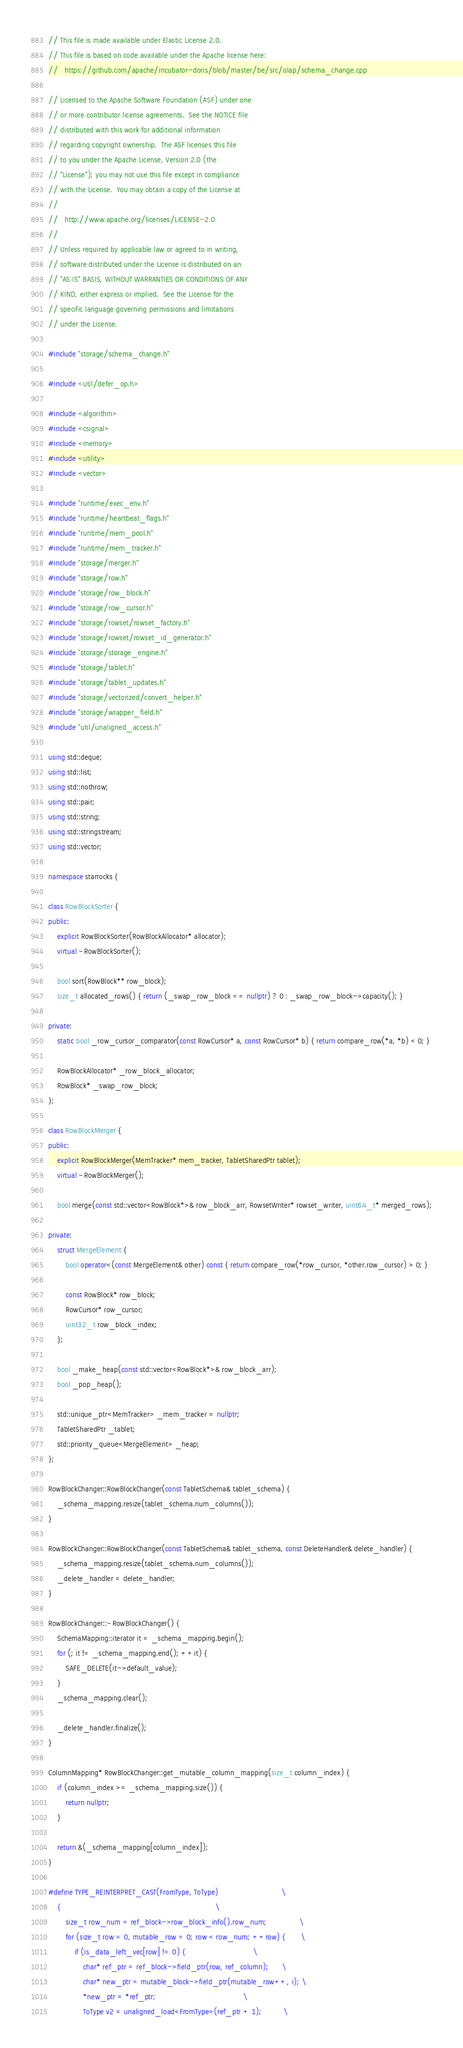Convert code to text. <code><loc_0><loc_0><loc_500><loc_500><_C++_>// This file is made available under Elastic License 2.0.
// This file is based on code available under the Apache license here:
//   https://github.com/apache/incubator-doris/blob/master/be/src/olap/schema_change.cpp

// Licensed to the Apache Software Foundation (ASF) under one
// or more contributor license agreements.  See the NOTICE file
// distributed with this work for additional information
// regarding copyright ownership.  The ASF licenses this file
// to you under the Apache License, Version 2.0 (the
// "License"); you may not use this file except in compliance
// with the License.  You may obtain a copy of the License at
//
//   http://www.apache.org/licenses/LICENSE-2.0
//
// Unless required by applicable law or agreed to in writing,
// software distributed under the License is distributed on an
// "AS IS" BASIS, WITHOUT WARRANTIES OR CONDITIONS OF ANY
// KIND, either express or implied.  See the License for the
// specific language governing permissions and limitations
// under the License.

#include "storage/schema_change.h"

#include <util/defer_op.h>

#include <algorithm>
#include <csignal>
#include <memory>
#include <utility>
#include <vector>

#include "runtime/exec_env.h"
#include "runtime/heartbeat_flags.h"
#include "runtime/mem_pool.h"
#include "runtime/mem_tracker.h"
#include "storage/merger.h"
#include "storage/row.h"
#include "storage/row_block.h"
#include "storage/row_cursor.h"
#include "storage/rowset/rowset_factory.h"
#include "storage/rowset/rowset_id_generator.h"
#include "storage/storage_engine.h"
#include "storage/tablet.h"
#include "storage/tablet_updates.h"
#include "storage/vectorized/convert_helper.h"
#include "storage/wrapper_field.h"
#include "util/unaligned_access.h"

using std::deque;
using std::list;
using std::nothrow;
using std::pair;
using std::string;
using std::stringstream;
using std::vector;

namespace starrocks {

class RowBlockSorter {
public:
    explicit RowBlockSorter(RowBlockAllocator* allocator);
    virtual ~RowBlockSorter();

    bool sort(RowBlock** row_block);
    size_t allocated_rows() { return (_swap_row_block == nullptr) ? 0 : _swap_row_block->capacity(); }

private:
    static bool _row_cursor_comparator(const RowCursor* a, const RowCursor* b) { return compare_row(*a, *b) < 0; }

    RowBlockAllocator* _row_block_allocator;
    RowBlock* _swap_row_block;
};

class RowBlockMerger {
public:
    explicit RowBlockMerger(MemTracker* mem_tracker, TabletSharedPtr tablet);
    virtual ~RowBlockMerger();

    bool merge(const std::vector<RowBlock*>& row_block_arr, RowsetWriter* rowset_writer, uint64_t* merged_rows);

private:
    struct MergeElement {
        bool operator<(const MergeElement& other) const { return compare_row(*row_cursor, *other.row_cursor) > 0; }

        const RowBlock* row_block;
        RowCursor* row_cursor;
        uint32_t row_block_index;
    };

    bool _make_heap(const std::vector<RowBlock*>& row_block_arr);
    bool _pop_heap();

    std::unique_ptr<MemTracker> _mem_tracker = nullptr;
    TabletSharedPtr _tablet;
    std::priority_queue<MergeElement> _heap;
};

RowBlockChanger::RowBlockChanger(const TabletSchema& tablet_schema) {
    _schema_mapping.resize(tablet_schema.num_columns());
}

RowBlockChanger::RowBlockChanger(const TabletSchema& tablet_schema, const DeleteHandler& delete_handler) {
    _schema_mapping.resize(tablet_schema.num_columns());
    _delete_handler = delete_handler;
}

RowBlockChanger::~RowBlockChanger() {
    SchemaMapping::iterator it = _schema_mapping.begin();
    for (; it != _schema_mapping.end(); ++it) {
        SAFE_DELETE(it->default_value);
    }
    _schema_mapping.clear();

    _delete_handler.finalize();
}

ColumnMapping* RowBlockChanger::get_mutable_column_mapping(size_t column_index) {
    if (column_index >= _schema_mapping.size()) {
        return nullptr;
    }

    return &(_schema_mapping[column_index]);
}

#define TYPE_REINTERPRET_CAST(FromType, ToType)                             \
    {                                                                       \
        size_t row_num = ref_block->row_block_info().row_num;               \
        for (size_t row = 0, mutable_row = 0; row < row_num; ++row) {       \
            if (is_data_left_vec[row] != 0) {                               \
                char* ref_ptr = ref_block->field_ptr(row, ref_column);      \
                char* new_ptr = mutable_block->field_ptr(mutable_row++, i); \
                *new_ptr = *ref_ptr;                                        \
                ToType v2 = unaligned_load<FromType>(ref_ptr + 1);          \</code> 